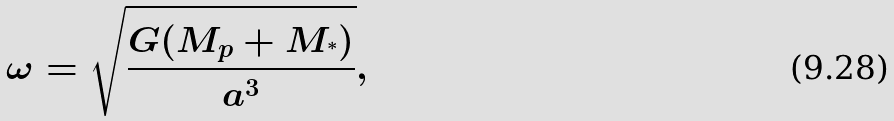Convert formula to latex. <formula><loc_0><loc_0><loc_500><loc_500>\omega = \sqrt { \frac { G ( M _ { p } + M _ { ^ { * } } ) } { a ^ { 3 } } } ,</formula> 